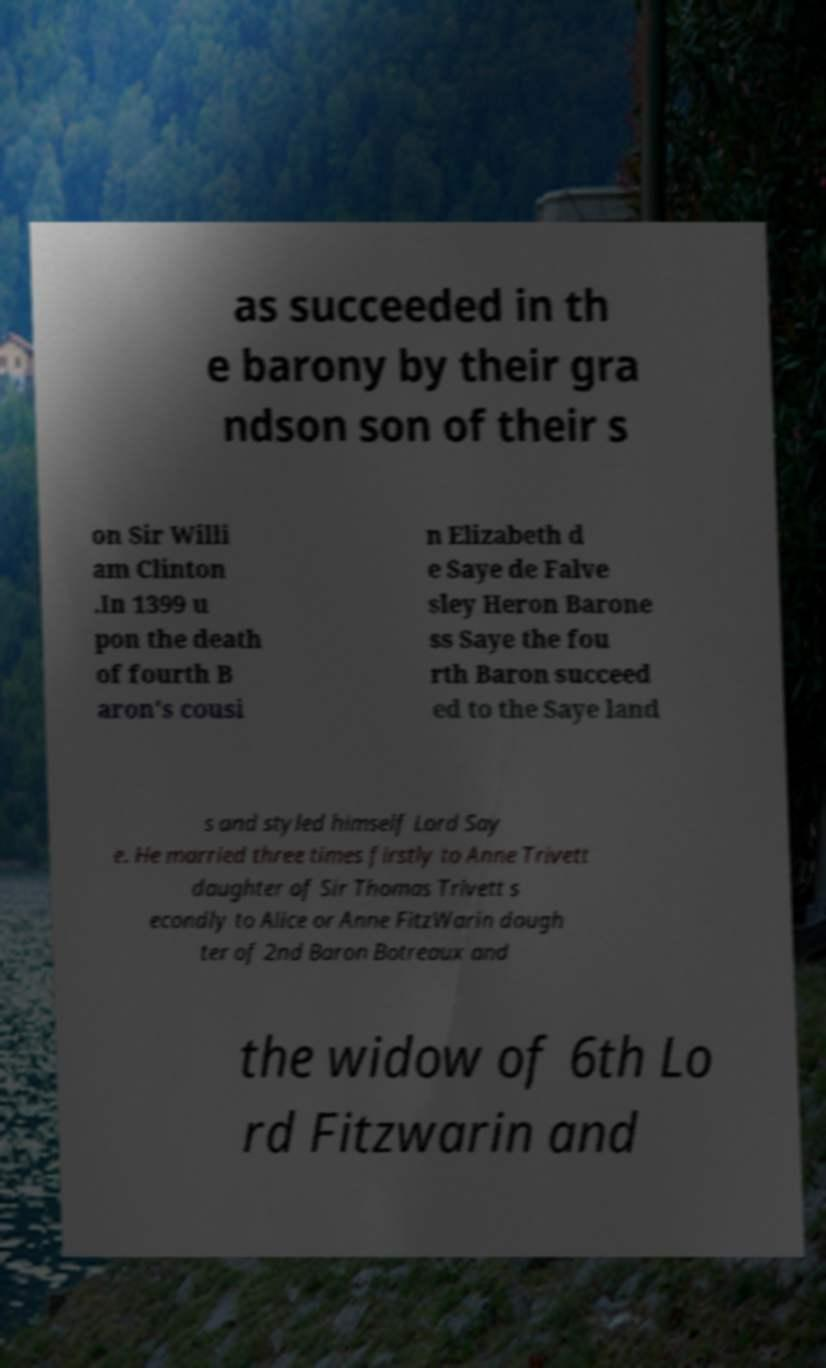Can you accurately transcribe the text from the provided image for me? as succeeded in th e barony by their gra ndson son of their s on Sir Willi am Clinton .In 1399 u pon the death of fourth B aron's cousi n Elizabeth d e Saye de Falve sley Heron Barone ss Saye the fou rth Baron succeed ed to the Saye land s and styled himself Lord Say e. He married three times firstly to Anne Trivett daughter of Sir Thomas Trivett s econdly to Alice or Anne FitzWarin daugh ter of 2nd Baron Botreaux and the widow of 6th Lo rd Fitzwarin and 